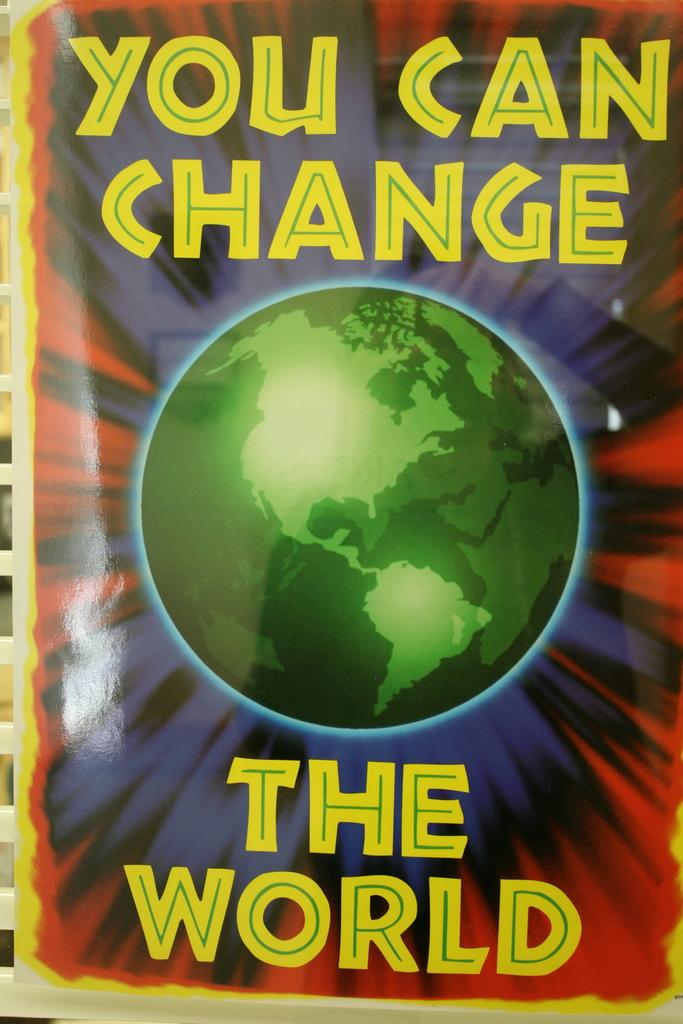Provide a one-sentence caption for the provided image. A poster that says you can change the world. 